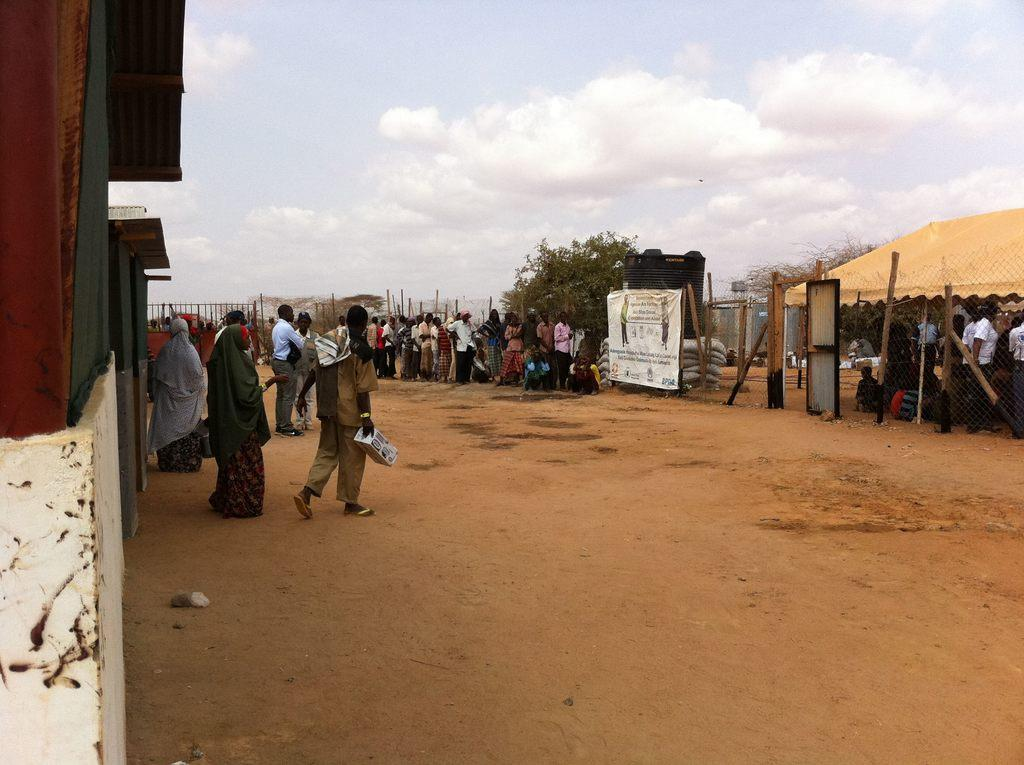How many people are in the image? There are people in the image, but the exact number is not specified. What can be seen hanging or displayed in the image? There is a banner in the image. What type of natural vegetation is present in the image? There are trees in the image. What type of container is visible in the image? There is a container in the image. What architectural feature can be seen in the image? There is a door in the image. What type of material is present in the image? There is a mesh in the image. What type of temporary shelter is visible in the image? There is a tent in the image. What type of man-made structure is visible in the image? There is a wall in the image. What type of objects are present in the image? There are objects in the image, but their specific nature is not specified. What can be seen in the background of the image? The sky with clouds is visible in the background of the image. What type of wave can be seen crashing on the shore in the image? There is no wave or shore present in the image. What type of downtown area can be seen in the image? There is no downtown area present in the image. 